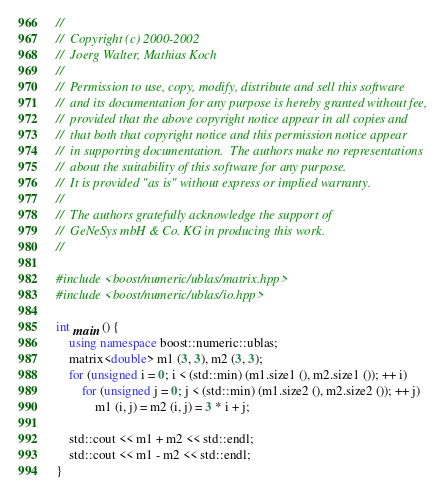<code> <loc_0><loc_0><loc_500><loc_500><_C++_>//
//  Copyright (c) 2000-2002
//  Joerg Walter, Mathias Koch
//
//  Permission to use, copy, modify, distribute and sell this software
//  and its documentation for any purpose is hereby granted without fee,
//  provided that the above copyright notice appear in all copies and
//  that both that copyright notice and this permission notice appear
//  in supporting documentation.  The authors make no representations
//  about the suitability of this software for any purpose.
//  It is provided "as is" without express or implied warranty.
//
//  The authors gratefully acknowledge the support of
//  GeNeSys mbH & Co. KG in producing this work.
//

#include <boost/numeric/ublas/matrix.hpp>
#include <boost/numeric/ublas/io.hpp>

int main () {
    using namespace boost::numeric::ublas;
    matrix<double> m1 (3, 3), m2 (3, 3);
    for (unsigned i = 0; i < (std::min) (m1.size1 (), m2.size1 ()); ++ i)
        for (unsigned j = 0; j < (std::min) (m1.size2 (), m2.size2 ()); ++ j)
            m1 (i, j) = m2 (i, j) = 3 * i + j;

    std::cout << m1 + m2 << std::endl;
    std::cout << m1 - m2 << std::endl;
}

</code> 